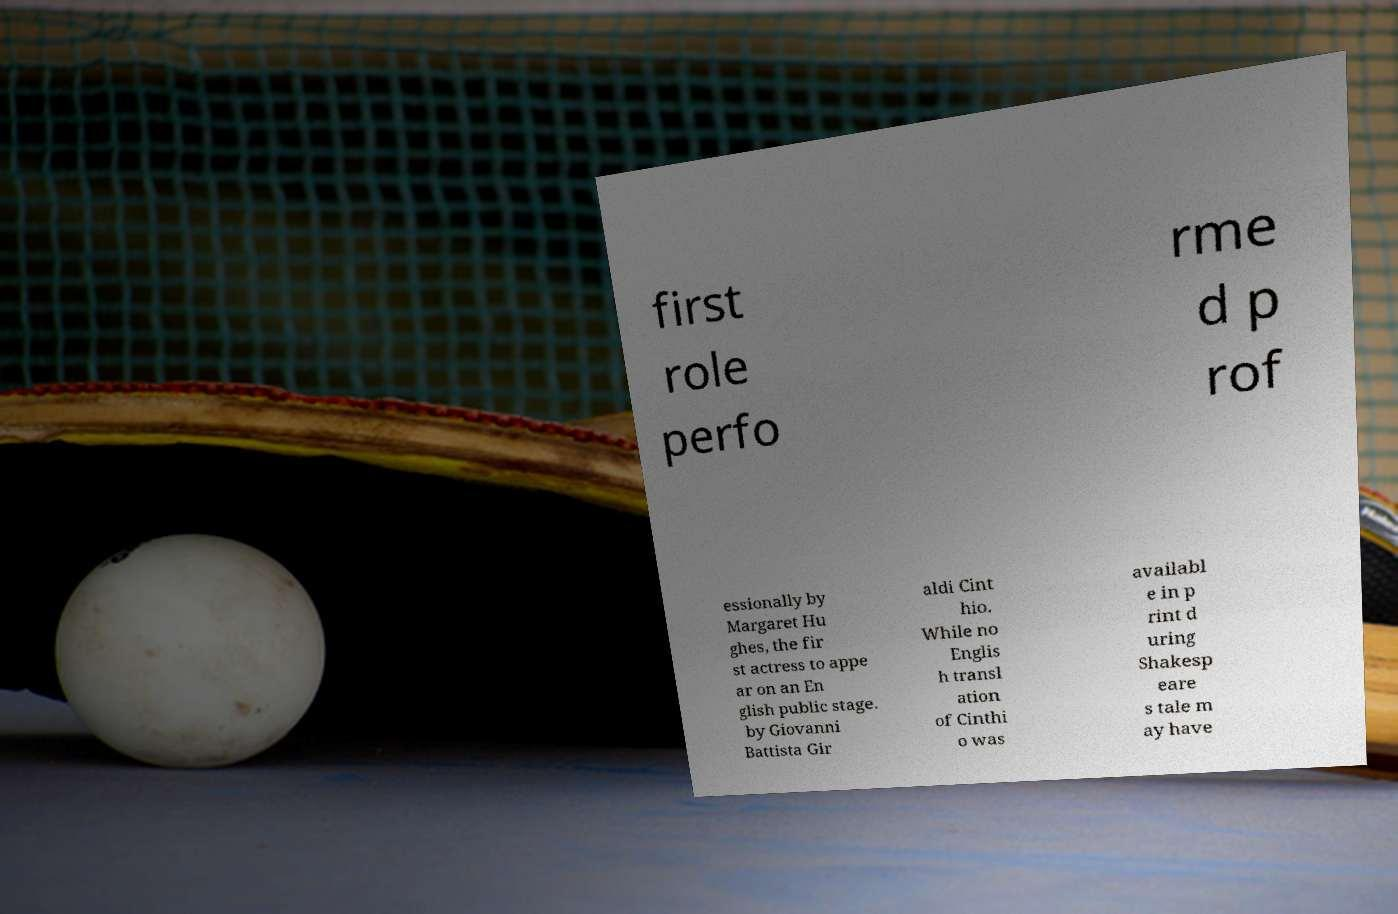Could you extract and type out the text from this image? first role perfo rme d p rof essionally by Margaret Hu ghes, the fir st actress to appe ar on an En glish public stage. by Giovanni Battista Gir aldi Cint hio. While no Englis h transl ation of Cinthi o was availabl e in p rint d uring Shakesp eare s tale m ay have 